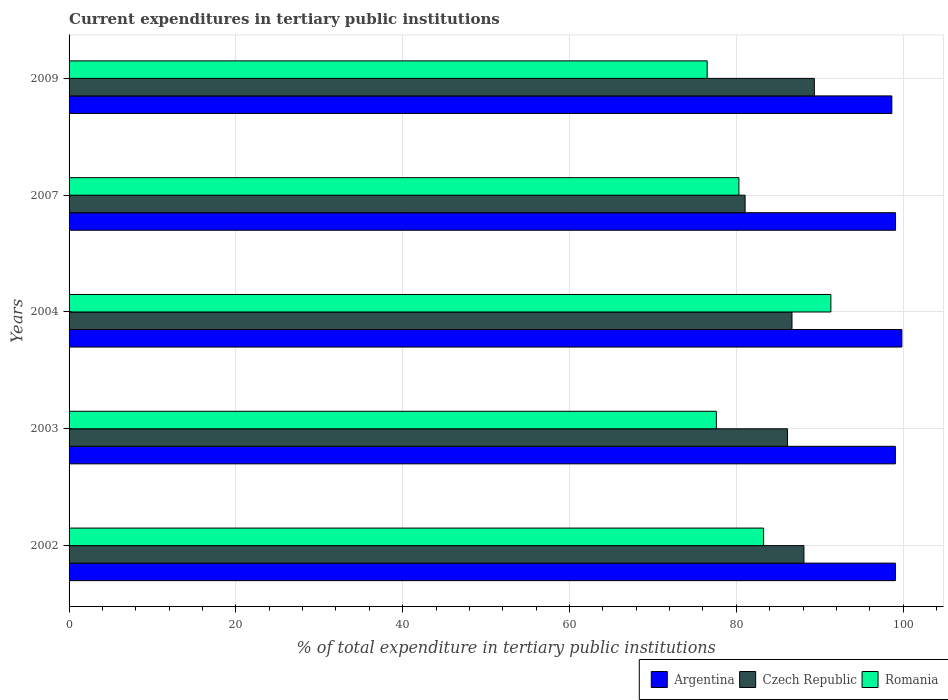How many different coloured bars are there?
Ensure brevity in your answer.  3. How many groups of bars are there?
Offer a very short reply. 5. How many bars are there on the 1st tick from the top?
Ensure brevity in your answer.  3. What is the label of the 1st group of bars from the top?
Your answer should be compact. 2009. In how many cases, is the number of bars for a given year not equal to the number of legend labels?
Provide a short and direct response. 0. What is the current expenditures in tertiary public institutions in Romania in 2009?
Your answer should be very brief. 76.5. Across all years, what is the maximum current expenditures in tertiary public institutions in Argentina?
Provide a succinct answer. 99.84. Across all years, what is the minimum current expenditures in tertiary public institutions in Argentina?
Keep it short and to the point. 98.64. In which year was the current expenditures in tertiary public institutions in Romania minimum?
Your answer should be very brief. 2009. What is the total current expenditures in tertiary public institutions in Argentina in the graph?
Give a very brief answer. 495.7. What is the difference between the current expenditures in tertiary public institutions in Czech Republic in 2002 and that in 2003?
Your answer should be very brief. 1.97. What is the difference between the current expenditures in tertiary public institutions in Czech Republic in 2007 and the current expenditures in tertiary public institutions in Romania in 2002?
Give a very brief answer. -2.22. What is the average current expenditures in tertiary public institutions in Czech Republic per year?
Keep it short and to the point. 86.26. In the year 2004, what is the difference between the current expenditures in tertiary public institutions in Argentina and current expenditures in tertiary public institutions in Romania?
Your response must be concise. 8.51. In how many years, is the current expenditures in tertiary public institutions in Czech Republic greater than 88 %?
Provide a short and direct response. 2. What is the ratio of the current expenditures in tertiary public institutions in Argentina in 2003 to that in 2004?
Provide a succinct answer. 0.99. Is the current expenditures in tertiary public institutions in Czech Republic in 2002 less than that in 2007?
Your answer should be compact. No. What is the difference between the highest and the second highest current expenditures in tertiary public institutions in Czech Republic?
Provide a succinct answer. 1.25. What is the difference between the highest and the lowest current expenditures in tertiary public institutions in Romania?
Keep it short and to the point. 14.83. In how many years, is the current expenditures in tertiary public institutions in Argentina greater than the average current expenditures in tertiary public institutions in Argentina taken over all years?
Make the answer very short. 1. Is the sum of the current expenditures in tertiary public institutions in Romania in 2003 and 2007 greater than the maximum current expenditures in tertiary public institutions in Argentina across all years?
Your answer should be very brief. Yes. What does the 1st bar from the top in 2002 represents?
Keep it short and to the point. Romania. Are all the bars in the graph horizontal?
Your response must be concise. Yes. How many years are there in the graph?
Provide a succinct answer. 5. Are the values on the major ticks of X-axis written in scientific E-notation?
Keep it short and to the point. No. Does the graph contain grids?
Keep it short and to the point. Yes. How many legend labels are there?
Your answer should be very brief. 3. How are the legend labels stacked?
Provide a succinct answer. Horizontal. What is the title of the graph?
Your response must be concise. Current expenditures in tertiary public institutions. Does "Iraq" appear as one of the legend labels in the graph?
Keep it short and to the point. No. What is the label or title of the X-axis?
Make the answer very short. % of total expenditure in tertiary public institutions. What is the % of total expenditure in tertiary public institutions of Argentina in 2002?
Make the answer very short. 99.07. What is the % of total expenditure in tertiary public institutions in Czech Republic in 2002?
Keep it short and to the point. 88.1. What is the % of total expenditure in tertiary public institutions in Romania in 2002?
Give a very brief answer. 83.27. What is the % of total expenditure in tertiary public institutions of Argentina in 2003?
Provide a short and direct response. 99.06. What is the % of total expenditure in tertiary public institutions of Czech Republic in 2003?
Offer a very short reply. 86.13. What is the % of total expenditure in tertiary public institutions of Romania in 2003?
Provide a succinct answer. 77.6. What is the % of total expenditure in tertiary public institutions of Argentina in 2004?
Ensure brevity in your answer.  99.84. What is the % of total expenditure in tertiary public institutions in Czech Republic in 2004?
Keep it short and to the point. 86.67. What is the % of total expenditure in tertiary public institutions in Romania in 2004?
Your response must be concise. 91.33. What is the % of total expenditure in tertiary public institutions in Argentina in 2007?
Keep it short and to the point. 99.08. What is the % of total expenditure in tertiary public institutions of Czech Republic in 2007?
Keep it short and to the point. 81.05. What is the % of total expenditure in tertiary public institutions of Romania in 2007?
Offer a terse response. 80.31. What is the % of total expenditure in tertiary public institutions of Argentina in 2009?
Your response must be concise. 98.64. What is the % of total expenditure in tertiary public institutions in Czech Republic in 2009?
Make the answer very short. 89.35. What is the % of total expenditure in tertiary public institutions of Romania in 2009?
Your response must be concise. 76.5. Across all years, what is the maximum % of total expenditure in tertiary public institutions of Argentina?
Offer a very short reply. 99.84. Across all years, what is the maximum % of total expenditure in tertiary public institutions of Czech Republic?
Provide a succinct answer. 89.35. Across all years, what is the maximum % of total expenditure in tertiary public institutions of Romania?
Offer a terse response. 91.33. Across all years, what is the minimum % of total expenditure in tertiary public institutions in Argentina?
Offer a very short reply. 98.64. Across all years, what is the minimum % of total expenditure in tertiary public institutions of Czech Republic?
Keep it short and to the point. 81.05. Across all years, what is the minimum % of total expenditure in tertiary public institutions of Romania?
Give a very brief answer. 76.5. What is the total % of total expenditure in tertiary public institutions of Argentina in the graph?
Your answer should be compact. 495.7. What is the total % of total expenditure in tertiary public institutions of Czech Republic in the graph?
Make the answer very short. 431.3. What is the total % of total expenditure in tertiary public institutions in Romania in the graph?
Offer a very short reply. 409.01. What is the difference between the % of total expenditure in tertiary public institutions of Argentina in 2002 and that in 2003?
Provide a short and direct response. 0. What is the difference between the % of total expenditure in tertiary public institutions in Czech Republic in 2002 and that in 2003?
Provide a succinct answer. 1.97. What is the difference between the % of total expenditure in tertiary public institutions of Romania in 2002 and that in 2003?
Offer a very short reply. 5.66. What is the difference between the % of total expenditure in tertiary public institutions in Argentina in 2002 and that in 2004?
Provide a short and direct response. -0.77. What is the difference between the % of total expenditure in tertiary public institutions in Czech Republic in 2002 and that in 2004?
Offer a very short reply. 1.43. What is the difference between the % of total expenditure in tertiary public institutions in Romania in 2002 and that in 2004?
Keep it short and to the point. -8.06. What is the difference between the % of total expenditure in tertiary public institutions of Argentina in 2002 and that in 2007?
Make the answer very short. -0.02. What is the difference between the % of total expenditure in tertiary public institutions of Czech Republic in 2002 and that in 2007?
Offer a very short reply. 7.05. What is the difference between the % of total expenditure in tertiary public institutions in Romania in 2002 and that in 2007?
Your response must be concise. 2.96. What is the difference between the % of total expenditure in tertiary public institutions in Argentina in 2002 and that in 2009?
Offer a terse response. 0.43. What is the difference between the % of total expenditure in tertiary public institutions of Czech Republic in 2002 and that in 2009?
Your answer should be very brief. -1.25. What is the difference between the % of total expenditure in tertiary public institutions in Romania in 2002 and that in 2009?
Make the answer very short. 6.77. What is the difference between the % of total expenditure in tertiary public institutions of Argentina in 2003 and that in 2004?
Your response must be concise. -0.78. What is the difference between the % of total expenditure in tertiary public institutions in Czech Republic in 2003 and that in 2004?
Give a very brief answer. -0.53. What is the difference between the % of total expenditure in tertiary public institutions of Romania in 2003 and that in 2004?
Ensure brevity in your answer.  -13.73. What is the difference between the % of total expenditure in tertiary public institutions of Argentina in 2003 and that in 2007?
Keep it short and to the point. -0.02. What is the difference between the % of total expenditure in tertiary public institutions of Czech Republic in 2003 and that in 2007?
Keep it short and to the point. 5.09. What is the difference between the % of total expenditure in tertiary public institutions of Romania in 2003 and that in 2007?
Offer a very short reply. -2.7. What is the difference between the % of total expenditure in tertiary public institutions in Argentina in 2003 and that in 2009?
Keep it short and to the point. 0.42. What is the difference between the % of total expenditure in tertiary public institutions in Czech Republic in 2003 and that in 2009?
Your answer should be very brief. -3.21. What is the difference between the % of total expenditure in tertiary public institutions of Romania in 2003 and that in 2009?
Your answer should be compact. 1.1. What is the difference between the % of total expenditure in tertiary public institutions of Argentina in 2004 and that in 2007?
Give a very brief answer. 0.76. What is the difference between the % of total expenditure in tertiary public institutions of Czech Republic in 2004 and that in 2007?
Your response must be concise. 5.62. What is the difference between the % of total expenditure in tertiary public institutions of Romania in 2004 and that in 2007?
Give a very brief answer. 11.03. What is the difference between the % of total expenditure in tertiary public institutions in Argentina in 2004 and that in 2009?
Keep it short and to the point. 1.2. What is the difference between the % of total expenditure in tertiary public institutions in Czech Republic in 2004 and that in 2009?
Offer a terse response. -2.68. What is the difference between the % of total expenditure in tertiary public institutions in Romania in 2004 and that in 2009?
Your response must be concise. 14.83. What is the difference between the % of total expenditure in tertiary public institutions in Argentina in 2007 and that in 2009?
Your answer should be very brief. 0.44. What is the difference between the % of total expenditure in tertiary public institutions in Czech Republic in 2007 and that in 2009?
Make the answer very short. -8.3. What is the difference between the % of total expenditure in tertiary public institutions in Romania in 2007 and that in 2009?
Give a very brief answer. 3.81. What is the difference between the % of total expenditure in tertiary public institutions of Argentina in 2002 and the % of total expenditure in tertiary public institutions of Czech Republic in 2003?
Offer a terse response. 12.93. What is the difference between the % of total expenditure in tertiary public institutions of Argentina in 2002 and the % of total expenditure in tertiary public institutions of Romania in 2003?
Offer a very short reply. 21.46. What is the difference between the % of total expenditure in tertiary public institutions of Czech Republic in 2002 and the % of total expenditure in tertiary public institutions of Romania in 2003?
Make the answer very short. 10.5. What is the difference between the % of total expenditure in tertiary public institutions in Argentina in 2002 and the % of total expenditure in tertiary public institutions in Czech Republic in 2004?
Offer a very short reply. 12.4. What is the difference between the % of total expenditure in tertiary public institutions of Argentina in 2002 and the % of total expenditure in tertiary public institutions of Romania in 2004?
Your answer should be compact. 7.73. What is the difference between the % of total expenditure in tertiary public institutions in Czech Republic in 2002 and the % of total expenditure in tertiary public institutions in Romania in 2004?
Give a very brief answer. -3.23. What is the difference between the % of total expenditure in tertiary public institutions in Argentina in 2002 and the % of total expenditure in tertiary public institutions in Czech Republic in 2007?
Your answer should be very brief. 18.02. What is the difference between the % of total expenditure in tertiary public institutions in Argentina in 2002 and the % of total expenditure in tertiary public institutions in Romania in 2007?
Provide a short and direct response. 18.76. What is the difference between the % of total expenditure in tertiary public institutions in Czech Republic in 2002 and the % of total expenditure in tertiary public institutions in Romania in 2007?
Keep it short and to the point. 7.8. What is the difference between the % of total expenditure in tertiary public institutions in Argentina in 2002 and the % of total expenditure in tertiary public institutions in Czech Republic in 2009?
Make the answer very short. 9.72. What is the difference between the % of total expenditure in tertiary public institutions of Argentina in 2002 and the % of total expenditure in tertiary public institutions of Romania in 2009?
Offer a terse response. 22.57. What is the difference between the % of total expenditure in tertiary public institutions in Czech Republic in 2002 and the % of total expenditure in tertiary public institutions in Romania in 2009?
Keep it short and to the point. 11.6. What is the difference between the % of total expenditure in tertiary public institutions of Argentina in 2003 and the % of total expenditure in tertiary public institutions of Czech Republic in 2004?
Give a very brief answer. 12.39. What is the difference between the % of total expenditure in tertiary public institutions of Argentina in 2003 and the % of total expenditure in tertiary public institutions of Romania in 2004?
Your answer should be compact. 7.73. What is the difference between the % of total expenditure in tertiary public institutions of Czech Republic in 2003 and the % of total expenditure in tertiary public institutions of Romania in 2004?
Offer a very short reply. -5.2. What is the difference between the % of total expenditure in tertiary public institutions of Argentina in 2003 and the % of total expenditure in tertiary public institutions of Czech Republic in 2007?
Your answer should be compact. 18.01. What is the difference between the % of total expenditure in tertiary public institutions of Argentina in 2003 and the % of total expenditure in tertiary public institutions of Romania in 2007?
Your answer should be compact. 18.76. What is the difference between the % of total expenditure in tertiary public institutions of Czech Republic in 2003 and the % of total expenditure in tertiary public institutions of Romania in 2007?
Ensure brevity in your answer.  5.83. What is the difference between the % of total expenditure in tertiary public institutions in Argentina in 2003 and the % of total expenditure in tertiary public institutions in Czech Republic in 2009?
Give a very brief answer. 9.71. What is the difference between the % of total expenditure in tertiary public institutions of Argentina in 2003 and the % of total expenditure in tertiary public institutions of Romania in 2009?
Make the answer very short. 22.56. What is the difference between the % of total expenditure in tertiary public institutions of Czech Republic in 2003 and the % of total expenditure in tertiary public institutions of Romania in 2009?
Provide a succinct answer. 9.63. What is the difference between the % of total expenditure in tertiary public institutions in Argentina in 2004 and the % of total expenditure in tertiary public institutions in Czech Republic in 2007?
Ensure brevity in your answer.  18.79. What is the difference between the % of total expenditure in tertiary public institutions of Argentina in 2004 and the % of total expenditure in tertiary public institutions of Romania in 2007?
Your response must be concise. 19.53. What is the difference between the % of total expenditure in tertiary public institutions of Czech Republic in 2004 and the % of total expenditure in tertiary public institutions of Romania in 2007?
Provide a succinct answer. 6.36. What is the difference between the % of total expenditure in tertiary public institutions in Argentina in 2004 and the % of total expenditure in tertiary public institutions in Czech Republic in 2009?
Give a very brief answer. 10.49. What is the difference between the % of total expenditure in tertiary public institutions of Argentina in 2004 and the % of total expenditure in tertiary public institutions of Romania in 2009?
Give a very brief answer. 23.34. What is the difference between the % of total expenditure in tertiary public institutions of Czech Republic in 2004 and the % of total expenditure in tertiary public institutions of Romania in 2009?
Provide a short and direct response. 10.17. What is the difference between the % of total expenditure in tertiary public institutions in Argentina in 2007 and the % of total expenditure in tertiary public institutions in Czech Republic in 2009?
Ensure brevity in your answer.  9.74. What is the difference between the % of total expenditure in tertiary public institutions of Argentina in 2007 and the % of total expenditure in tertiary public institutions of Romania in 2009?
Your response must be concise. 22.58. What is the difference between the % of total expenditure in tertiary public institutions in Czech Republic in 2007 and the % of total expenditure in tertiary public institutions in Romania in 2009?
Make the answer very short. 4.55. What is the average % of total expenditure in tertiary public institutions of Argentina per year?
Offer a terse response. 99.14. What is the average % of total expenditure in tertiary public institutions in Czech Republic per year?
Ensure brevity in your answer.  86.26. What is the average % of total expenditure in tertiary public institutions of Romania per year?
Ensure brevity in your answer.  81.8. In the year 2002, what is the difference between the % of total expenditure in tertiary public institutions in Argentina and % of total expenditure in tertiary public institutions in Czech Republic?
Offer a very short reply. 10.96. In the year 2002, what is the difference between the % of total expenditure in tertiary public institutions in Argentina and % of total expenditure in tertiary public institutions in Romania?
Ensure brevity in your answer.  15.8. In the year 2002, what is the difference between the % of total expenditure in tertiary public institutions in Czech Republic and % of total expenditure in tertiary public institutions in Romania?
Your response must be concise. 4.83. In the year 2003, what is the difference between the % of total expenditure in tertiary public institutions in Argentina and % of total expenditure in tertiary public institutions in Czech Republic?
Make the answer very short. 12.93. In the year 2003, what is the difference between the % of total expenditure in tertiary public institutions of Argentina and % of total expenditure in tertiary public institutions of Romania?
Provide a succinct answer. 21.46. In the year 2003, what is the difference between the % of total expenditure in tertiary public institutions in Czech Republic and % of total expenditure in tertiary public institutions in Romania?
Offer a terse response. 8.53. In the year 2004, what is the difference between the % of total expenditure in tertiary public institutions in Argentina and % of total expenditure in tertiary public institutions in Czech Republic?
Your answer should be compact. 13.17. In the year 2004, what is the difference between the % of total expenditure in tertiary public institutions of Argentina and % of total expenditure in tertiary public institutions of Romania?
Your answer should be very brief. 8.51. In the year 2004, what is the difference between the % of total expenditure in tertiary public institutions of Czech Republic and % of total expenditure in tertiary public institutions of Romania?
Your answer should be very brief. -4.66. In the year 2007, what is the difference between the % of total expenditure in tertiary public institutions in Argentina and % of total expenditure in tertiary public institutions in Czech Republic?
Give a very brief answer. 18.04. In the year 2007, what is the difference between the % of total expenditure in tertiary public institutions in Argentina and % of total expenditure in tertiary public institutions in Romania?
Keep it short and to the point. 18.78. In the year 2007, what is the difference between the % of total expenditure in tertiary public institutions in Czech Republic and % of total expenditure in tertiary public institutions in Romania?
Ensure brevity in your answer.  0.74. In the year 2009, what is the difference between the % of total expenditure in tertiary public institutions of Argentina and % of total expenditure in tertiary public institutions of Czech Republic?
Your answer should be compact. 9.29. In the year 2009, what is the difference between the % of total expenditure in tertiary public institutions in Argentina and % of total expenditure in tertiary public institutions in Romania?
Make the answer very short. 22.14. In the year 2009, what is the difference between the % of total expenditure in tertiary public institutions in Czech Republic and % of total expenditure in tertiary public institutions in Romania?
Provide a succinct answer. 12.85. What is the ratio of the % of total expenditure in tertiary public institutions of Argentina in 2002 to that in 2003?
Offer a very short reply. 1. What is the ratio of the % of total expenditure in tertiary public institutions in Czech Republic in 2002 to that in 2003?
Give a very brief answer. 1.02. What is the ratio of the % of total expenditure in tertiary public institutions of Romania in 2002 to that in 2003?
Ensure brevity in your answer.  1.07. What is the ratio of the % of total expenditure in tertiary public institutions of Argentina in 2002 to that in 2004?
Provide a short and direct response. 0.99. What is the ratio of the % of total expenditure in tertiary public institutions of Czech Republic in 2002 to that in 2004?
Offer a terse response. 1.02. What is the ratio of the % of total expenditure in tertiary public institutions of Romania in 2002 to that in 2004?
Provide a short and direct response. 0.91. What is the ratio of the % of total expenditure in tertiary public institutions in Czech Republic in 2002 to that in 2007?
Your response must be concise. 1.09. What is the ratio of the % of total expenditure in tertiary public institutions in Romania in 2002 to that in 2007?
Offer a terse response. 1.04. What is the ratio of the % of total expenditure in tertiary public institutions in Argentina in 2002 to that in 2009?
Give a very brief answer. 1. What is the ratio of the % of total expenditure in tertiary public institutions in Czech Republic in 2002 to that in 2009?
Give a very brief answer. 0.99. What is the ratio of the % of total expenditure in tertiary public institutions in Romania in 2002 to that in 2009?
Provide a short and direct response. 1.09. What is the ratio of the % of total expenditure in tertiary public institutions of Czech Republic in 2003 to that in 2004?
Ensure brevity in your answer.  0.99. What is the ratio of the % of total expenditure in tertiary public institutions in Romania in 2003 to that in 2004?
Offer a terse response. 0.85. What is the ratio of the % of total expenditure in tertiary public institutions of Czech Republic in 2003 to that in 2007?
Offer a terse response. 1.06. What is the ratio of the % of total expenditure in tertiary public institutions of Romania in 2003 to that in 2007?
Provide a short and direct response. 0.97. What is the ratio of the % of total expenditure in tertiary public institutions in Argentina in 2003 to that in 2009?
Ensure brevity in your answer.  1. What is the ratio of the % of total expenditure in tertiary public institutions in Czech Republic in 2003 to that in 2009?
Offer a terse response. 0.96. What is the ratio of the % of total expenditure in tertiary public institutions of Romania in 2003 to that in 2009?
Provide a short and direct response. 1.01. What is the ratio of the % of total expenditure in tertiary public institutions of Argentina in 2004 to that in 2007?
Offer a terse response. 1.01. What is the ratio of the % of total expenditure in tertiary public institutions of Czech Republic in 2004 to that in 2007?
Keep it short and to the point. 1.07. What is the ratio of the % of total expenditure in tertiary public institutions of Romania in 2004 to that in 2007?
Give a very brief answer. 1.14. What is the ratio of the % of total expenditure in tertiary public institutions of Argentina in 2004 to that in 2009?
Give a very brief answer. 1.01. What is the ratio of the % of total expenditure in tertiary public institutions in Czech Republic in 2004 to that in 2009?
Make the answer very short. 0.97. What is the ratio of the % of total expenditure in tertiary public institutions of Romania in 2004 to that in 2009?
Make the answer very short. 1.19. What is the ratio of the % of total expenditure in tertiary public institutions in Argentina in 2007 to that in 2009?
Offer a very short reply. 1. What is the ratio of the % of total expenditure in tertiary public institutions in Czech Republic in 2007 to that in 2009?
Your response must be concise. 0.91. What is the ratio of the % of total expenditure in tertiary public institutions in Romania in 2007 to that in 2009?
Provide a succinct answer. 1.05. What is the difference between the highest and the second highest % of total expenditure in tertiary public institutions in Argentina?
Your response must be concise. 0.76. What is the difference between the highest and the second highest % of total expenditure in tertiary public institutions of Czech Republic?
Your answer should be very brief. 1.25. What is the difference between the highest and the second highest % of total expenditure in tertiary public institutions of Romania?
Offer a very short reply. 8.06. What is the difference between the highest and the lowest % of total expenditure in tertiary public institutions in Argentina?
Your answer should be compact. 1.2. What is the difference between the highest and the lowest % of total expenditure in tertiary public institutions of Czech Republic?
Offer a very short reply. 8.3. What is the difference between the highest and the lowest % of total expenditure in tertiary public institutions of Romania?
Your response must be concise. 14.83. 